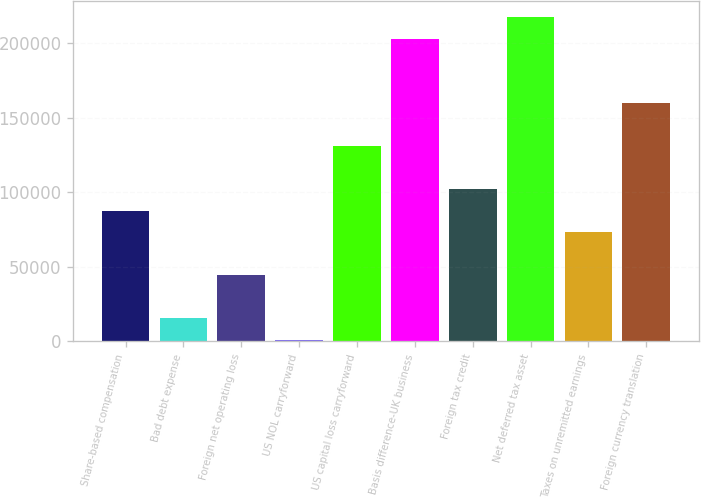<chart> <loc_0><loc_0><loc_500><loc_500><bar_chart><fcel>Share-based compensation<fcel>Bad debt expense<fcel>Foreign net operating loss<fcel>US NOL carryforward<fcel>US capital loss carryforward<fcel>Basis difference-UK business<fcel>Foreign tax credit<fcel>Net deferred tax asset<fcel>Taxes on unremitted earnings<fcel>Foreign currency translation<nl><fcel>87554.4<fcel>15494.9<fcel>44318.7<fcel>1083<fcel>130790<fcel>202850<fcel>101966<fcel>217262<fcel>73142.5<fcel>159614<nl></chart> 